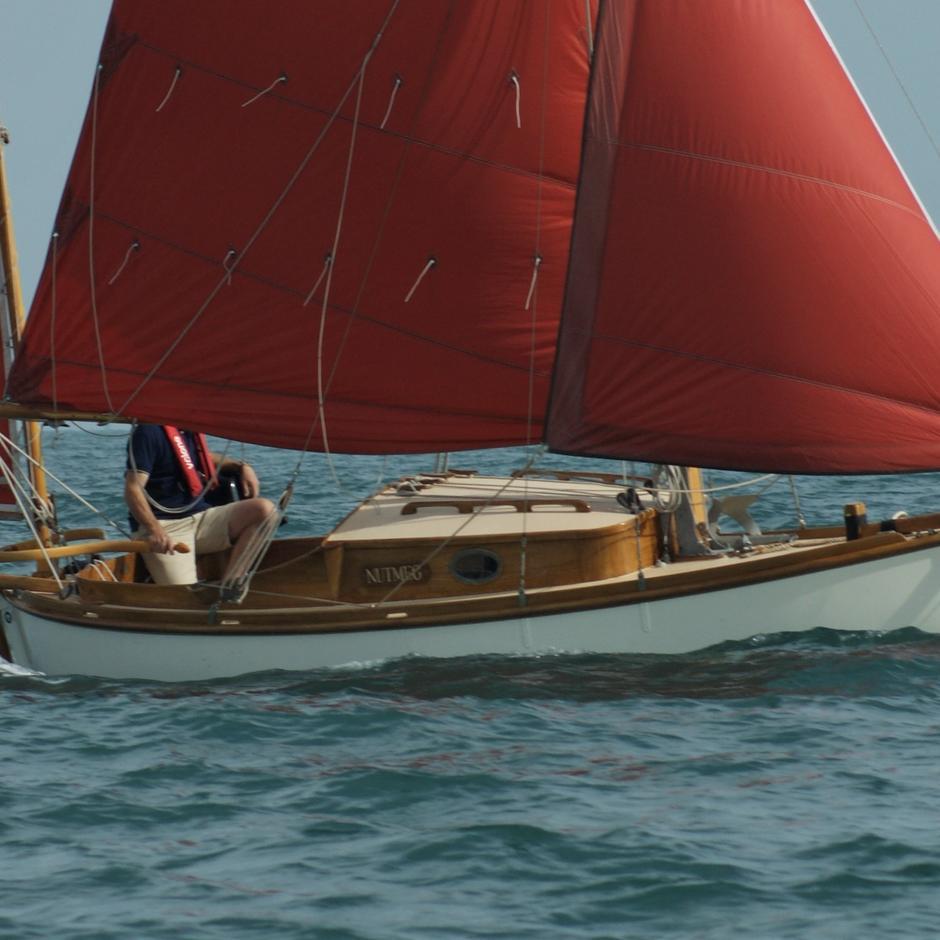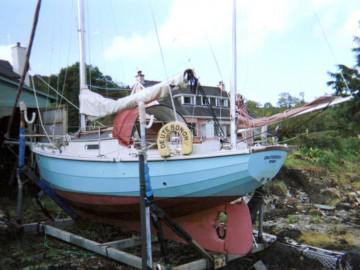The first image is the image on the left, the second image is the image on the right. Examine the images to the left and right. Is the description "n at least one image there are two red sails on a boat in the water." accurate? Answer yes or no. Yes. The first image is the image on the left, the second image is the image on the right. Evaluate the accuracy of this statement regarding the images: "A sailboat on open water in one image has red sails and at least one person on the boat.". Is it true? Answer yes or no. Yes. 